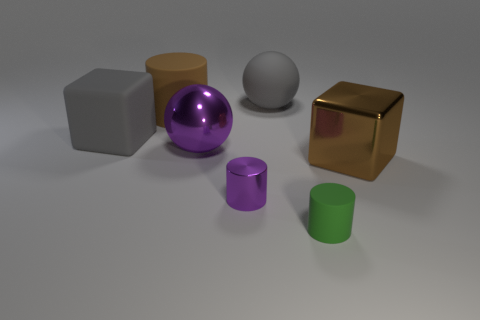How many large shiny objects are to the left of the large object that is to the right of the big rubber thing that is to the right of the large cylinder?
Provide a succinct answer. 1. What shape is the large object behind the matte cylinder behind the large cube left of the brown metallic object?
Give a very brief answer. Sphere. What number of other objects are the same color as the big metallic block?
Keep it short and to the point. 1. What is the shape of the big thing behind the cylinder behind the large metallic cube?
Your answer should be very brief. Sphere. There is a brown metallic thing; what number of brown metal cubes are behind it?
Make the answer very short. 0. Is there a small red block that has the same material as the purple cylinder?
Provide a short and direct response. No. What is the material of the cylinder that is the same size as the gray cube?
Your response must be concise. Rubber. There is a object that is both behind the brown block and in front of the big gray matte block; what size is it?
Offer a very short reply. Large. What is the color of the cylinder that is in front of the big brown rubber object and on the left side of the tiny green cylinder?
Keep it short and to the point. Purple. Is the number of tiny purple metal cylinders behind the large purple metal sphere less than the number of balls that are to the right of the small green thing?
Offer a terse response. No. 